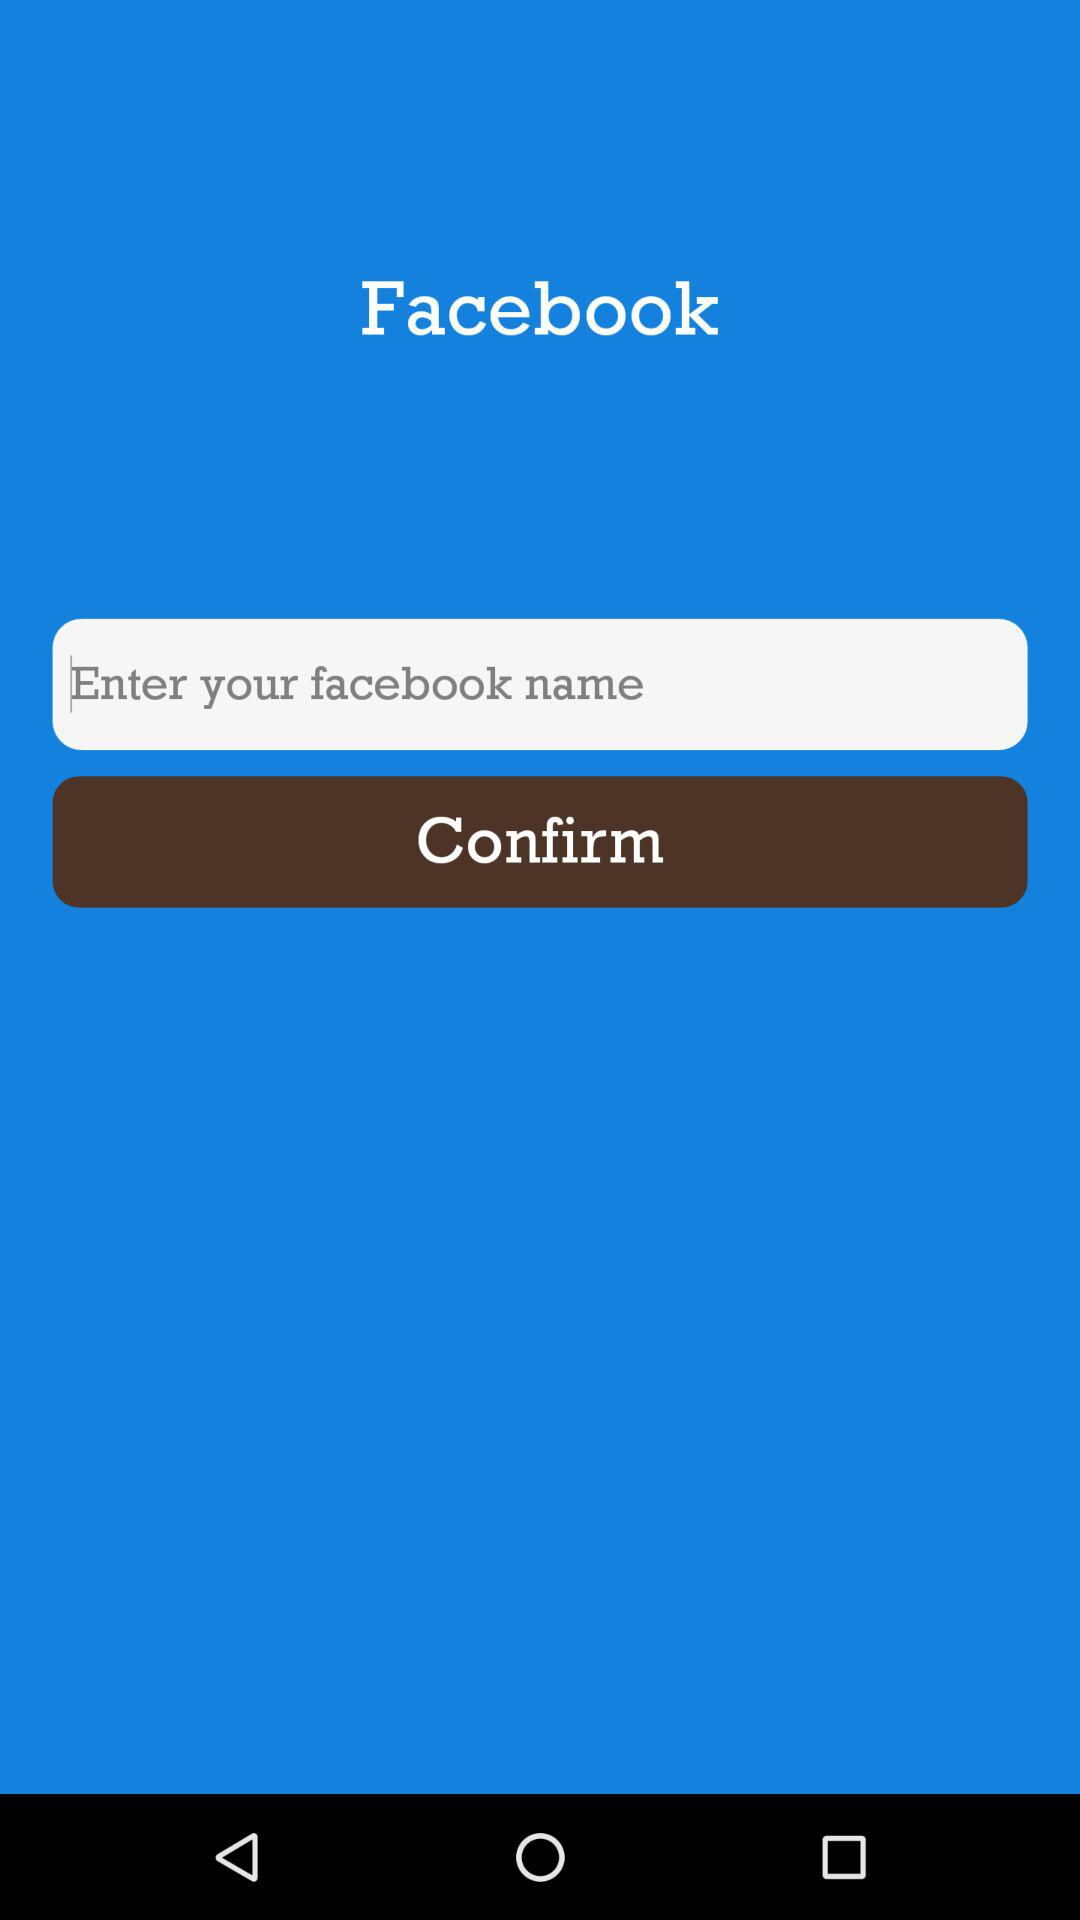What is the app name? The app name is "Facebook". 